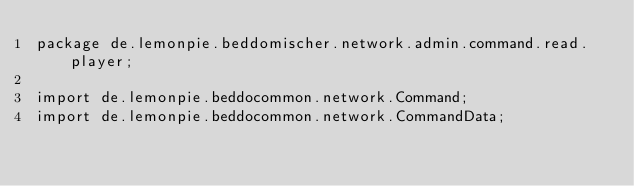Convert code to text. <code><loc_0><loc_0><loc_500><loc_500><_Java_>package de.lemonpie.beddomischer.network.admin.command.read.player;

import de.lemonpie.beddocommon.network.Command;
import de.lemonpie.beddocommon.network.CommandData;</code> 